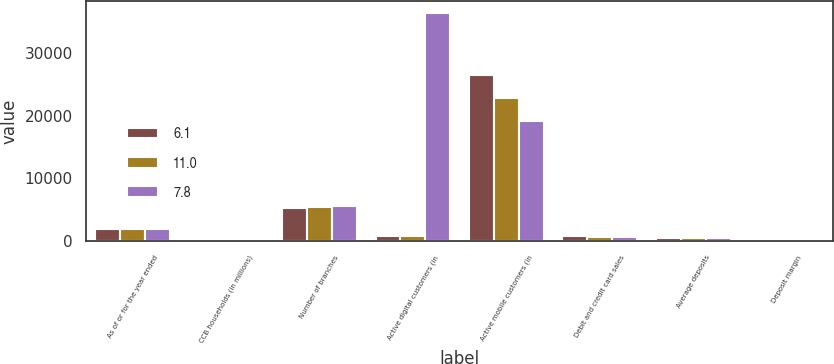Convert chart. <chart><loc_0><loc_0><loc_500><loc_500><stacked_bar_chart><ecel><fcel>As of or for the year ended<fcel>CCB households (in millions)<fcel>Number of branches<fcel>Active digital customers (in<fcel>Active mobile customers (in<fcel>Debit and credit card sales<fcel>Average deposits<fcel>Deposit margin<nl><fcel>6.1<fcel>2016<fcel>60<fcel>5258<fcel>785.85<fcel>26536<fcel>817.9<fcel>570.8<fcel>1.81<nl><fcel>11<fcel>2015<fcel>57.8<fcel>5413<fcel>785.85<fcel>22810<fcel>753.8<fcel>515.2<fcel>1.9<nl><fcel>7.8<fcel>2014<fcel>57.2<fcel>5602<fcel>36396<fcel>19084<fcel>707<fcel>472.3<fcel>2.21<nl></chart> 